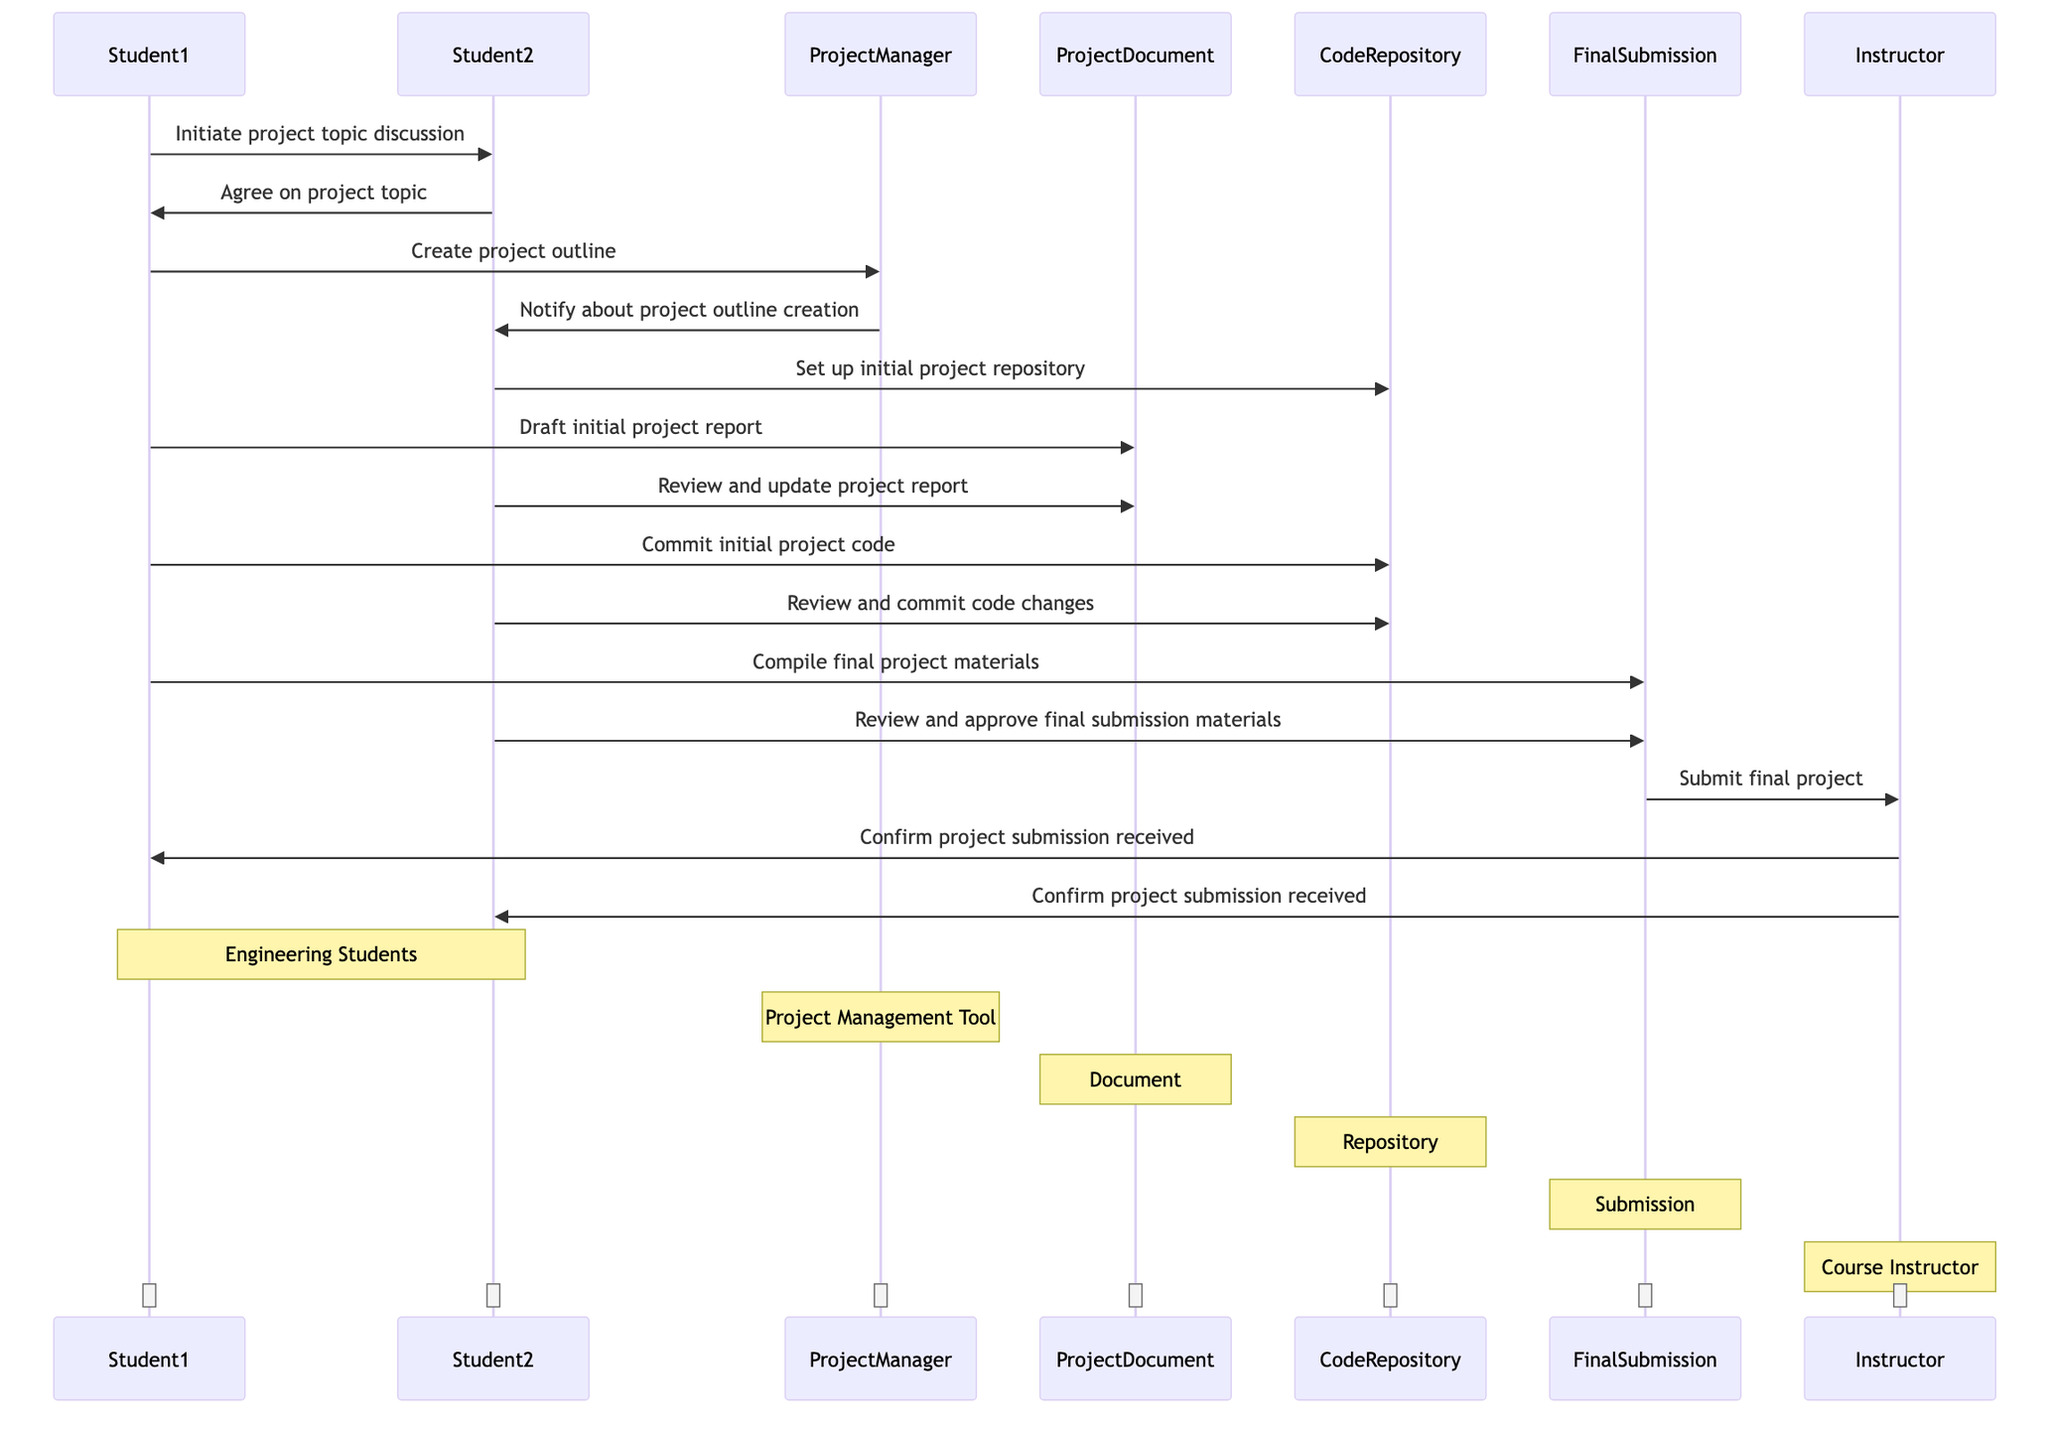What is the first message exchanged in the diagram? The first message in the sequence flows from Student1 to Student2, which states, "Initiate project topic discussion." This is shown at the beginning of the diagram.
Answer: Initiate project topic discussion How many actors are involved in the collaboration? The diagram presents four actors: Student1, Student2, ProjectManager, and Instructor. Counting each person and role yields a total of four.
Answer: 4 What does Student2 do after receiving the project outline notification? After receiving the notification about the project outline creation from ProjectManager, Student2 sets up the initial project repository. This step is indicated in the diagram immediately following the notification.
Answer: Set up initial project repository What is the final action taken before submission? The final action before submission is the review and approval of the final submission materials by Student2, which takes place after Student1 compiles the final project materials. This sequence of messages leads directly to the submission step.
Answer: Review and approve final submission materials Who is notified after the final project submission? The Instructor is notified after the final project submission, as shown by the messages sent from FinalSubmission to Instructor to indicate that the submission was made.
Answer: Instructor 